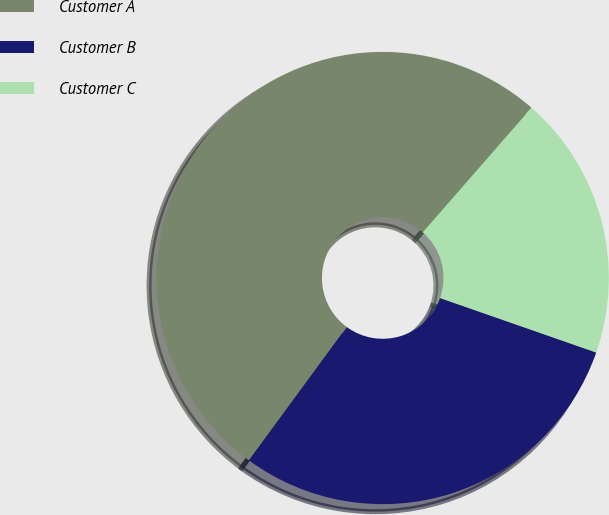Convert chart. <chart><loc_0><loc_0><loc_500><loc_500><pie_chart><fcel>Customer A<fcel>Customer B<fcel>Customer C<nl><fcel>51.35%<fcel>29.73%<fcel>18.92%<nl></chart> 